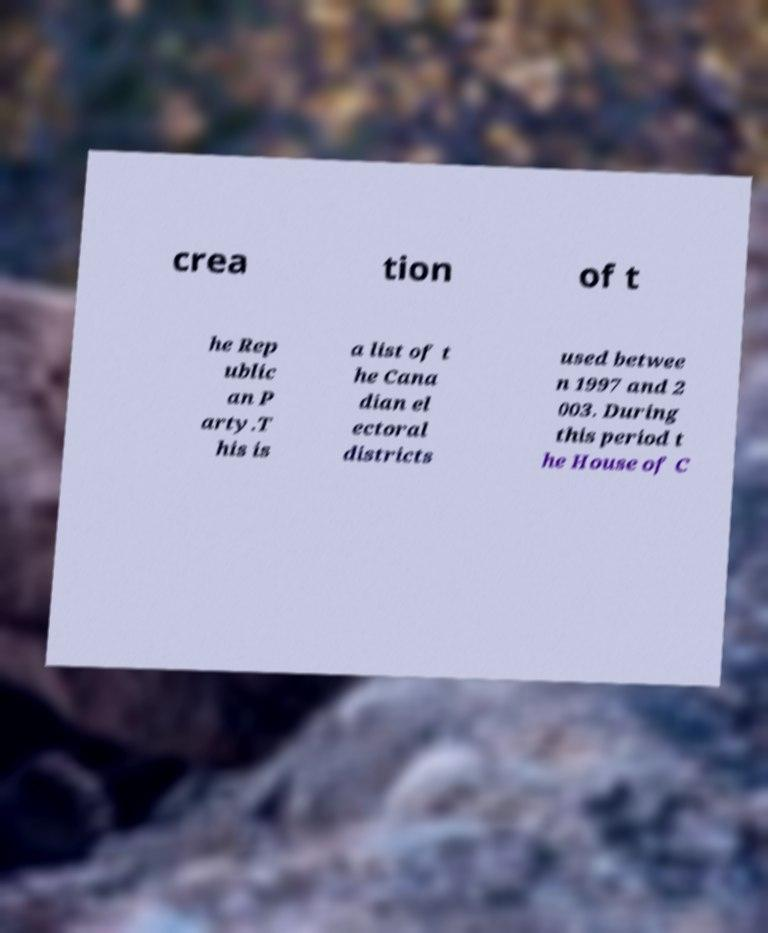Could you assist in decoding the text presented in this image and type it out clearly? crea tion of t he Rep ublic an P arty.T his is a list of t he Cana dian el ectoral districts used betwee n 1997 and 2 003. During this period t he House of C 